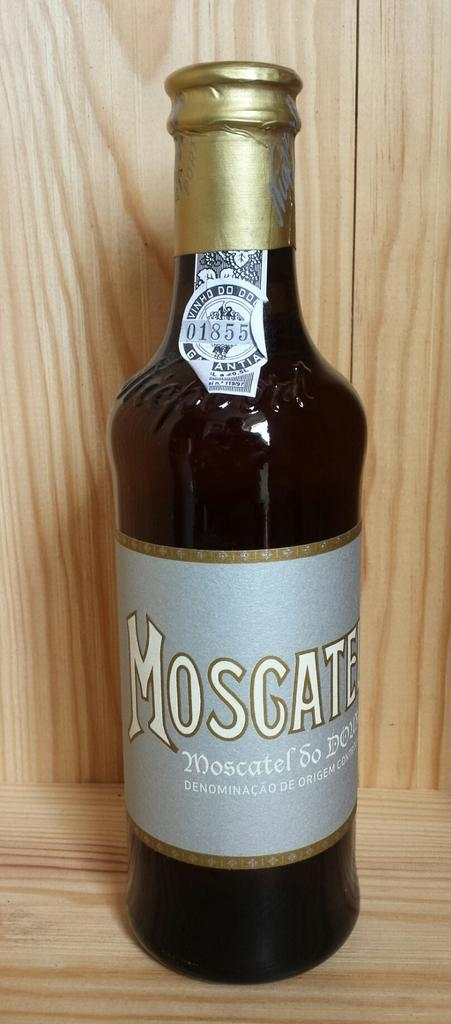<image>
Give a short and clear explanation of the subsequent image. A bottle has the number 01855 on a label that is peeling off. 